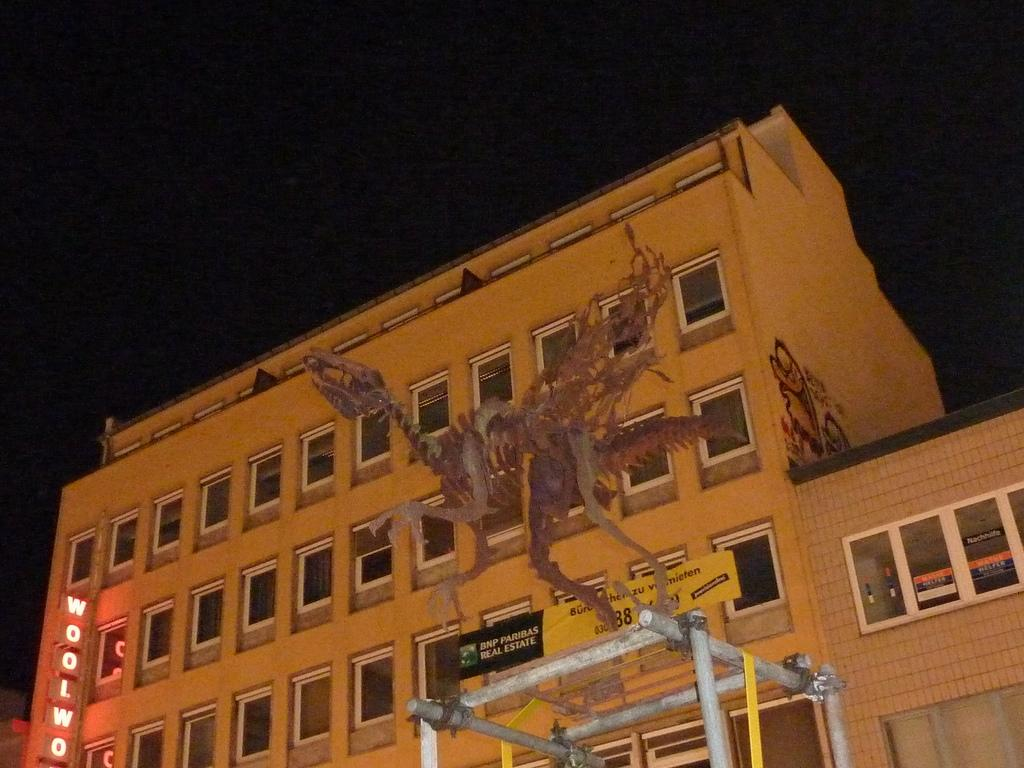What is the main subject of the image? The main subject of the image is a skeleton of a dragon. What can be seen in the background of the image? There is a building with windows in the background of the image. What is on the building in the image? There is a light board on the building. What is visible in the sky in the image? The sky is visible in the image. How does the stem of the dragon help it move in the image? There is no stem present in the image, as the subject is a skeleton of a dragon. Additionally, dragons do not have stems, as they are mythical creatures. 